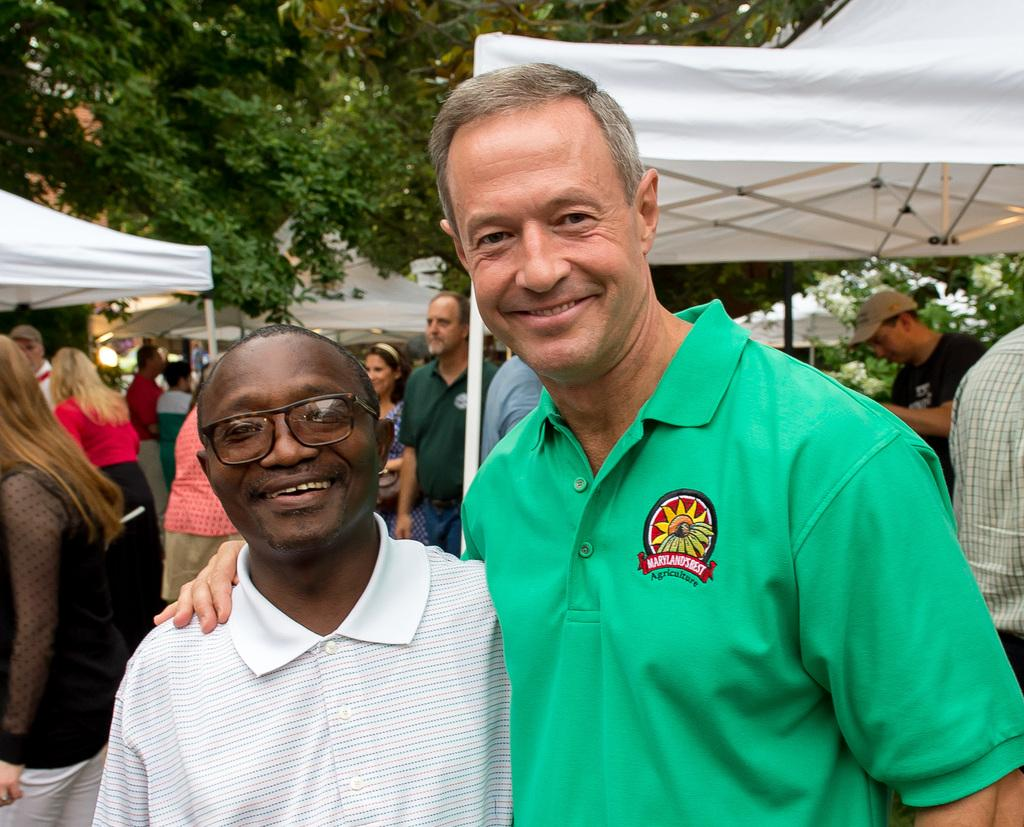How many people are present in the image? There are two people in the image. What is the facial expression of the people in the image? The two people are smiling. What can be seen in the background of the image? There is a group of people, tents, and trees in the background of the image. What type of process is being carried out by the oranges in the image? There are no oranges present in the image, so no process involving oranges can be observed. Is there an attack happening in the image? There is no indication of an attack in the image; the people are smiling, and there are no signs of conflict or danger. 